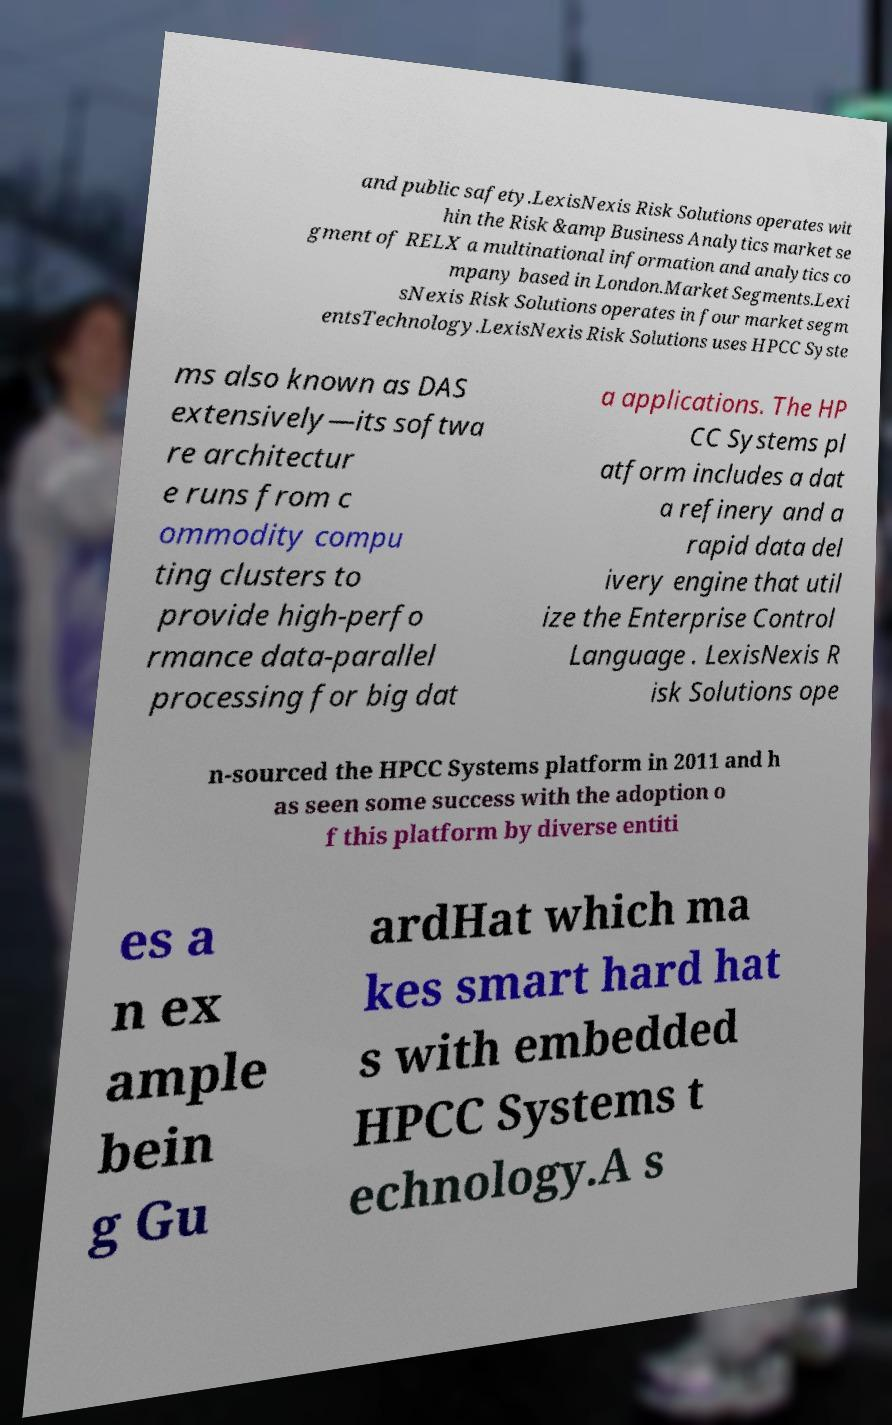Could you extract and type out the text from this image? and public safety.LexisNexis Risk Solutions operates wit hin the Risk &amp Business Analytics market se gment of RELX a multinational information and analytics co mpany based in London.Market Segments.Lexi sNexis Risk Solutions operates in four market segm entsTechnology.LexisNexis Risk Solutions uses HPCC Syste ms also known as DAS extensively—its softwa re architectur e runs from c ommodity compu ting clusters to provide high-perfo rmance data-parallel processing for big dat a applications. The HP CC Systems pl atform includes a dat a refinery and a rapid data del ivery engine that util ize the Enterprise Control Language . LexisNexis R isk Solutions ope n-sourced the HPCC Systems platform in 2011 and h as seen some success with the adoption o f this platform by diverse entiti es a n ex ample bein g Gu ardHat which ma kes smart hard hat s with embedded HPCC Systems t echnology.A s 